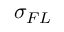<formula> <loc_0><loc_0><loc_500><loc_500>\sigma _ { F L }</formula> 